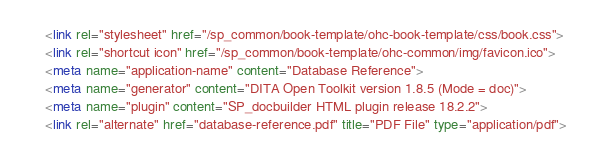<code> <loc_0><loc_0><loc_500><loc_500><_HTML_>      <link rel="stylesheet" href="/sp_common/book-template/ohc-book-template/css/book.css">
      <link rel="shortcut icon" href="/sp_common/book-template/ohc-common/img/favicon.ico">
      <meta name="application-name" content="Database Reference">
      <meta name="generator" content="DITA Open Toolkit version 1.8.5 (Mode = doc)">
      <meta name="plugin" content="SP_docbuilder HTML plugin release 18.2.2">
      <link rel="alternate" href="database-reference.pdf" title="PDF File" type="application/pdf"></code> 